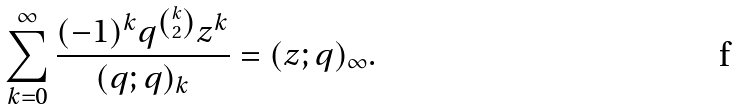<formula> <loc_0><loc_0><loc_500><loc_500>\sum _ { k = 0 } ^ { \infty } \frac { ( - 1 ) ^ { k } q ^ { k \choose 2 } z ^ { k } } { ( q ; q ) _ { k } } = ( z ; q ) _ { \infty } .</formula> 